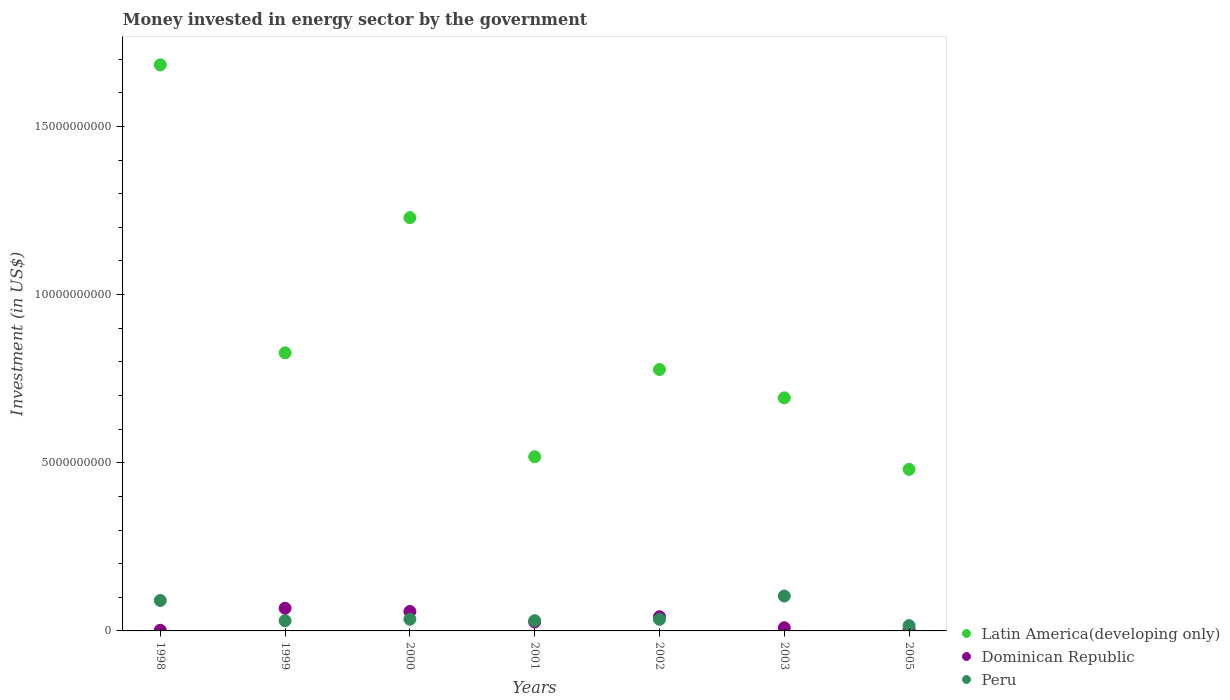What is the money spent in energy sector in Dominican Republic in 2000?
Ensure brevity in your answer.  5.77e+08. Across all years, what is the maximum money spent in energy sector in Latin America(developing only)?
Offer a very short reply. 1.68e+1. In which year was the money spent in energy sector in Dominican Republic maximum?
Your response must be concise. 1999. In which year was the money spent in energy sector in Latin America(developing only) minimum?
Provide a short and direct response. 2005. What is the total money spent in energy sector in Peru in the graph?
Your response must be concise. 3.40e+09. What is the difference between the money spent in energy sector in Peru in 2001 and that in 2005?
Offer a terse response. 1.46e+08. What is the difference between the money spent in energy sector in Latin America(developing only) in 2002 and the money spent in energy sector in Peru in 2001?
Give a very brief answer. 7.47e+09. What is the average money spent in energy sector in Peru per year?
Provide a succinct answer. 4.86e+08. In the year 2000, what is the difference between the money spent in energy sector in Latin America(developing only) and money spent in energy sector in Peru?
Offer a very short reply. 1.19e+1. What is the ratio of the money spent in energy sector in Latin America(developing only) in 2000 to that in 2005?
Offer a very short reply. 2.56. Is the difference between the money spent in energy sector in Latin America(developing only) in 2001 and 2005 greater than the difference between the money spent in energy sector in Peru in 2001 and 2005?
Provide a succinct answer. Yes. What is the difference between the highest and the second highest money spent in energy sector in Dominican Republic?
Your answer should be very brief. 9.67e+07. What is the difference between the highest and the lowest money spent in energy sector in Peru?
Provide a short and direct response. 8.78e+08. Is the sum of the money spent in energy sector in Peru in 2001 and 2003 greater than the maximum money spent in energy sector in Latin America(developing only) across all years?
Make the answer very short. No. What is the difference between two consecutive major ticks on the Y-axis?
Offer a terse response. 5.00e+09. Are the values on the major ticks of Y-axis written in scientific E-notation?
Your answer should be very brief. No. Does the graph contain any zero values?
Offer a terse response. No. Does the graph contain grids?
Make the answer very short. No. How are the legend labels stacked?
Offer a terse response. Vertical. What is the title of the graph?
Your answer should be compact. Money invested in energy sector by the government. Does "Portugal" appear as one of the legend labels in the graph?
Your answer should be very brief. No. What is the label or title of the Y-axis?
Offer a terse response. Investment (in US$). What is the Investment (in US$) in Latin America(developing only) in 1998?
Give a very brief answer. 1.68e+1. What is the Investment (in US$) in Dominican Republic in 1998?
Provide a short and direct response. 2.00e+07. What is the Investment (in US$) in Peru in 1998?
Keep it short and to the point. 9.05e+08. What is the Investment (in US$) in Latin America(developing only) in 1999?
Provide a short and direct response. 8.27e+09. What is the Investment (in US$) in Dominican Republic in 1999?
Make the answer very short. 6.74e+08. What is the Investment (in US$) of Peru in 1999?
Your answer should be compact. 3.04e+08. What is the Investment (in US$) of Latin America(developing only) in 2000?
Your answer should be compact. 1.23e+1. What is the Investment (in US$) of Dominican Republic in 2000?
Offer a very short reply. 5.77e+08. What is the Investment (in US$) of Peru in 2000?
Offer a terse response. 3.48e+08. What is the Investment (in US$) of Latin America(developing only) in 2001?
Offer a terse response. 5.18e+09. What is the Investment (in US$) of Dominican Republic in 2001?
Ensure brevity in your answer.  2.65e+08. What is the Investment (in US$) of Peru in 2001?
Offer a very short reply. 3.04e+08. What is the Investment (in US$) of Latin America(developing only) in 2002?
Make the answer very short. 7.77e+09. What is the Investment (in US$) in Dominican Republic in 2002?
Keep it short and to the point. 4.22e+08. What is the Investment (in US$) in Peru in 2002?
Give a very brief answer. 3.45e+08. What is the Investment (in US$) of Latin America(developing only) in 2003?
Offer a very short reply. 6.93e+09. What is the Investment (in US$) in Dominican Republic in 2003?
Make the answer very short. 9.50e+07. What is the Investment (in US$) in Peru in 2003?
Offer a terse response. 1.04e+09. What is the Investment (in US$) in Latin America(developing only) in 2005?
Provide a short and direct response. 4.80e+09. What is the Investment (in US$) of Dominican Republic in 2005?
Offer a terse response. 4.25e+07. What is the Investment (in US$) of Peru in 2005?
Provide a succinct answer. 1.59e+08. Across all years, what is the maximum Investment (in US$) in Latin America(developing only)?
Your answer should be very brief. 1.68e+1. Across all years, what is the maximum Investment (in US$) in Dominican Republic?
Your answer should be compact. 6.74e+08. Across all years, what is the maximum Investment (in US$) in Peru?
Offer a terse response. 1.04e+09. Across all years, what is the minimum Investment (in US$) of Latin America(developing only)?
Your answer should be compact. 4.80e+09. Across all years, what is the minimum Investment (in US$) of Peru?
Your response must be concise. 1.59e+08. What is the total Investment (in US$) of Latin America(developing only) in the graph?
Your answer should be compact. 6.21e+1. What is the total Investment (in US$) of Dominican Republic in the graph?
Make the answer very short. 2.10e+09. What is the total Investment (in US$) of Peru in the graph?
Keep it short and to the point. 3.40e+09. What is the difference between the Investment (in US$) in Latin America(developing only) in 1998 and that in 1999?
Provide a succinct answer. 8.56e+09. What is the difference between the Investment (in US$) in Dominican Republic in 1998 and that in 1999?
Your answer should be compact. -6.54e+08. What is the difference between the Investment (in US$) in Peru in 1998 and that in 1999?
Your response must be concise. 6.01e+08. What is the difference between the Investment (in US$) in Latin America(developing only) in 1998 and that in 2000?
Provide a short and direct response. 4.54e+09. What is the difference between the Investment (in US$) of Dominican Republic in 1998 and that in 2000?
Keep it short and to the point. -5.57e+08. What is the difference between the Investment (in US$) of Peru in 1998 and that in 2000?
Offer a very short reply. 5.57e+08. What is the difference between the Investment (in US$) of Latin America(developing only) in 1998 and that in 2001?
Make the answer very short. 1.17e+1. What is the difference between the Investment (in US$) of Dominican Republic in 1998 and that in 2001?
Provide a succinct answer. -2.45e+08. What is the difference between the Investment (in US$) of Peru in 1998 and that in 2001?
Your answer should be very brief. 6.01e+08. What is the difference between the Investment (in US$) of Latin America(developing only) in 1998 and that in 2002?
Offer a terse response. 9.06e+09. What is the difference between the Investment (in US$) of Dominican Republic in 1998 and that in 2002?
Ensure brevity in your answer.  -4.02e+08. What is the difference between the Investment (in US$) of Peru in 1998 and that in 2002?
Provide a succinct answer. 5.60e+08. What is the difference between the Investment (in US$) in Latin America(developing only) in 1998 and that in 2003?
Offer a very short reply. 9.90e+09. What is the difference between the Investment (in US$) of Dominican Republic in 1998 and that in 2003?
Your answer should be compact. -7.50e+07. What is the difference between the Investment (in US$) of Peru in 1998 and that in 2003?
Offer a very short reply. -1.32e+08. What is the difference between the Investment (in US$) of Latin America(developing only) in 1998 and that in 2005?
Provide a short and direct response. 1.20e+1. What is the difference between the Investment (in US$) in Dominican Republic in 1998 and that in 2005?
Offer a very short reply. -2.25e+07. What is the difference between the Investment (in US$) in Peru in 1998 and that in 2005?
Provide a short and direct response. 7.46e+08. What is the difference between the Investment (in US$) of Latin America(developing only) in 1999 and that in 2000?
Your response must be concise. -4.02e+09. What is the difference between the Investment (in US$) of Dominican Republic in 1999 and that in 2000?
Give a very brief answer. 9.67e+07. What is the difference between the Investment (in US$) of Peru in 1999 and that in 2000?
Your answer should be compact. -4.37e+07. What is the difference between the Investment (in US$) of Latin America(developing only) in 1999 and that in 2001?
Give a very brief answer. 3.09e+09. What is the difference between the Investment (in US$) in Dominican Republic in 1999 and that in 2001?
Provide a succinct answer. 4.09e+08. What is the difference between the Investment (in US$) of Latin America(developing only) in 1999 and that in 2002?
Your answer should be very brief. 4.96e+08. What is the difference between the Investment (in US$) in Dominican Republic in 1999 and that in 2002?
Offer a very short reply. 2.52e+08. What is the difference between the Investment (in US$) in Peru in 1999 and that in 2002?
Provide a succinct answer. -4.09e+07. What is the difference between the Investment (in US$) in Latin America(developing only) in 1999 and that in 2003?
Your response must be concise. 1.34e+09. What is the difference between the Investment (in US$) in Dominican Republic in 1999 and that in 2003?
Offer a very short reply. 5.79e+08. What is the difference between the Investment (in US$) of Peru in 1999 and that in 2003?
Offer a very short reply. -7.33e+08. What is the difference between the Investment (in US$) of Latin America(developing only) in 1999 and that in 2005?
Make the answer very short. 3.46e+09. What is the difference between the Investment (in US$) of Dominican Republic in 1999 and that in 2005?
Ensure brevity in your answer.  6.32e+08. What is the difference between the Investment (in US$) in Peru in 1999 and that in 2005?
Provide a short and direct response. 1.46e+08. What is the difference between the Investment (in US$) of Latin America(developing only) in 2000 and that in 2001?
Your answer should be very brief. 7.11e+09. What is the difference between the Investment (in US$) in Dominican Republic in 2000 and that in 2001?
Your response must be concise. 3.12e+08. What is the difference between the Investment (in US$) of Peru in 2000 and that in 2001?
Offer a terse response. 4.38e+07. What is the difference between the Investment (in US$) in Latin America(developing only) in 2000 and that in 2002?
Ensure brevity in your answer.  4.52e+09. What is the difference between the Investment (in US$) of Dominican Republic in 2000 and that in 2002?
Provide a short and direct response. 1.56e+08. What is the difference between the Investment (in US$) of Peru in 2000 and that in 2002?
Provide a succinct answer. 2.80e+06. What is the difference between the Investment (in US$) of Latin America(developing only) in 2000 and that in 2003?
Your answer should be very brief. 5.36e+09. What is the difference between the Investment (in US$) of Dominican Republic in 2000 and that in 2003?
Provide a succinct answer. 4.82e+08. What is the difference between the Investment (in US$) of Peru in 2000 and that in 2003?
Your answer should be very brief. -6.89e+08. What is the difference between the Investment (in US$) of Latin America(developing only) in 2000 and that in 2005?
Offer a very short reply. 7.48e+09. What is the difference between the Investment (in US$) of Dominican Republic in 2000 and that in 2005?
Ensure brevity in your answer.  5.35e+08. What is the difference between the Investment (in US$) of Peru in 2000 and that in 2005?
Your response must be concise. 1.90e+08. What is the difference between the Investment (in US$) in Latin America(developing only) in 2001 and that in 2002?
Provide a succinct answer. -2.59e+09. What is the difference between the Investment (in US$) in Dominican Republic in 2001 and that in 2002?
Give a very brief answer. -1.57e+08. What is the difference between the Investment (in US$) in Peru in 2001 and that in 2002?
Your response must be concise. -4.10e+07. What is the difference between the Investment (in US$) of Latin America(developing only) in 2001 and that in 2003?
Give a very brief answer. -1.75e+09. What is the difference between the Investment (in US$) of Dominican Republic in 2001 and that in 2003?
Provide a succinct answer. 1.70e+08. What is the difference between the Investment (in US$) of Peru in 2001 and that in 2003?
Provide a short and direct response. -7.33e+08. What is the difference between the Investment (in US$) in Latin America(developing only) in 2001 and that in 2005?
Ensure brevity in your answer.  3.74e+08. What is the difference between the Investment (in US$) in Dominican Republic in 2001 and that in 2005?
Provide a short and direct response. 2.22e+08. What is the difference between the Investment (in US$) of Peru in 2001 and that in 2005?
Offer a very short reply. 1.46e+08. What is the difference between the Investment (in US$) of Latin America(developing only) in 2002 and that in 2003?
Offer a very short reply. 8.42e+08. What is the difference between the Investment (in US$) of Dominican Republic in 2002 and that in 2003?
Give a very brief answer. 3.27e+08. What is the difference between the Investment (in US$) of Peru in 2002 and that in 2003?
Keep it short and to the point. -6.92e+08. What is the difference between the Investment (in US$) of Latin America(developing only) in 2002 and that in 2005?
Offer a terse response. 2.97e+09. What is the difference between the Investment (in US$) of Dominican Republic in 2002 and that in 2005?
Your answer should be compact. 3.79e+08. What is the difference between the Investment (in US$) of Peru in 2002 and that in 2005?
Provide a succinct answer. 1.87e+08. What is the difference between the Investment (in US$) of Latin America(developing only) in 2003 and that in 2005?
Your response must be concise. 2.13e+09. What is the difference between the Investment (in US$) of Dominican Republic in 2003 and that in 2005?
Make the answer very short. 5.25e+07. What is the difference between the Investment (in US$) in Peru in 2003 and that in 2005?
Keep it short and to the point. 8.78e+08. What is the difference between the Investment (in US$) of Latin America(developing only) in 1998 and the Investment (in US$) of Dominican Republic in 1999?
Offer a terse response. 1.62e+1. What is the difference between the Investment (in US$) of Latin America(developing only) in 1998 and the Investment (in US$) of Peru in 1999?
Keep it short and to the point. 1.65e+1. What is the difference between the Investment (in US$) in Dominican Republic in 1998 and the Investment (in US$) in Peru in 1999?
Give a very brief answer. -2.84e+08. What is the difference between the Investment (in US$) in Latin America(developing only) in 1998 and the Investment (in US$) in Dominican Republic in 2000?
Offer a very short reply. 1.63e+1. What is the difference between the Investment (in US$) in Latin America(developing only) in 1998 and the Investment (in US$) in Peru in 2000?
Keep it short and to the point. 1.65e+1. What is the difference between the Investment (in US$) in Dominican Republic in 1998 and the Investment (in US$) in Peru in 2000?
Your response must be concise. -3.28e+08. What is the difference between the Investment (in US$) of Latin America(developing only) in 1998 and the Investment (in US$) of Dominican Republic in 2001?
Your answer should be very brief. 1.66e+1. What is the difference between the Investment (in US$) in Latin America(developing only) in 1998 and the Investment (in US$) in Peru in 2001?
Ensure brevity in your answer.  1.65e+1. What is the difference between the Investment (in US$) of Dominican Republic in 1998 and the Investment (in US$) of Peru in 2001?
Provide a succinct answer. -2.84e+08. What is the difference between the Investment (in US$) in Latin America(developing only) in 1998 and the Investment (in US$) in Dominican Republic in 2002?
Provide a succinct answer. 1.64e+1. What is the difference between the Investment (in US$) in Latin America(developing only) in 1998 and the Investment (in US$) in Peru in 2002?
Offer a terse response. 1.65e+1. What is the difference between the Investment (in US$) in Dominican Republic in 1998 and the Investment (in US$) in Peru in 2002?
Provide a succinct answer. -3.25e+08. What is the difference between the Investment (in US$) in Latin America(developing only) in 1998 and the Investment (in US$) in Dominican Republic in 2003?
Keep it short and to the point. 1.67e+1. What is the difference between the Investment (in US$) of Latin America(developing only) in 1998 and the Investment (in US$) of Peru in 2003?
Give a very brief answer. 1.58e+1. What is the difference between the Investment (in US$) of Dominican Republic in 1998 and the Investment (in US$) of Peru in 2003?
Give a very brief answer. -1.02e+09. What is the difference between the Investment (in US$) in Latin America(developing only) in 1998 and the Investment (in US$) in Dominican Republic in 2005?
Your response must be concise. 1.68e+1. What is the difference between the Investment (in US$) in Latin America(developing only) in 1998 and the Investment (in US$) in Peru in 2005?
Your answer should be very brief. 1.67e+1. What is the difference between the Investment (in US$) in Dominican Republic in 1998 and the Investment (in US$) in Peru in 2005?
Your answer should be compact. -1.39e+08. What is the difference between the Investment (in US$) of Latin America(developing only) in 1999 and the Investment (in US$) of Dominican Republic in 2000?
Your answer should be very brief. 7.69e+09. What is the difference between the Investment (in US$) in Latin America(developing only) in 1999 and the Investment (in US$) in Peru in 2000?
Keep it short and to the point. 7.92e+09. What is the difference between the Investment (in US$) in Dominican Republic in 1999 and the Investment (in US$) in Peru in 2000?
Offer a very short reply. 3.26e+08. What is the difference between the Investment (in US$) of Latin America(developing only) in 1999 and the Investment (in US$) of Dominican Republic in 2001?
Offer a terse response. 8.00e+09. What is the difference between the Investment (in US$) of Latin America(developing only) in 1999 and the Investment (in US$) of Peru in 2001?
Your response must be concise. 7.96e+09. What is the difference between the Investment (in US$) in Dominican Republic in 1999 and the Investment (in US$) in Peru in 2001?
Ensure brevity in your answer.  3.70e+08. What is the difference between the Investment (in US$) of Latin America(developing only) in 1999 and the Investment (in US$) of Dominican Republic in 2002?
Your answer should be very brief. 7.85e+09. What is the difference between the Investment (in US$) of Latin America(developing only) in 1999 and the Investment (in US$) of Peru in 2002?
Make the answer very short. 7.92e+09. What is the difference between the Investment (in US$) in Dominican Republic in 1999 and the Investment (in US$) in Peru in 2002?
Your response must be concise. 3.29e+08. What is the difference between the Investment (in US$) in Latin America(developing only) in 1999 and the Investment (in US$) in Dominican Republic in 2003?
Keep it short and to the point. 8.17e+09. What is the difference between the Investment (in US$) of Latin America(developing only) in 1999 and the Investment (in US$) of Peru in 2003?
Ensure brevity in your answer.  7.23e+09. What is the difference between the Investment (in US$) in Dominican Republic in 1999 and the Investment (in US$) in Peru in 2003?
Make the answer very short. -3.63e+08. What is the difference between the Investment (in US$) of Latin America(developing only) in 1999 and the Investment (in US$) of Dominican Republic in 2005?
Your answer should be compact. 8.23e+09. What is the difference between the Investment (in US$) of Latin America(developing only) in 1999 and the Investment (in US$) of Peru in 2005?
Provide a short and direct response. 8.11e+09. What is the difference between the Investment (in US$) of Dominican Republic in 1999 and the Investment (in US$) of Peru in 2005?
Keep it short and to the point. 5.15e+08. What is the difference between the Investment (in US$) in Latin America(developing only) in 2000 and the Investment (in US$) in Dominican Republic in 2001?
Ensure brevity in your answer.  1.20e+1. What is the difference between the Investment (in US$) of Latin America(developing only) in 2000 and the Investment (in US$) of Peru in 2001?
Provide a succinct answer. 1.20e+1. What is the difference between the Investment (in US$) of Dominican Republic in 2000 and the Investment (in US$) of Peru in 2001?
Your answer should be very brief. 2.73e+08. What is the difference between the Investment (in US$) of Latin America(developing only) in 2000 and the Investment (in US$) of Dominican Republic in 2002?
Your response must be concise. 1.19e+1. What is the difference between the Investment (in US$) of Latin America(developing only) in 2000 and the Investment (in US$) of Peru in 2002?
Provide a short and direct response. 1.19e+1. What is the difference between the Investment (in US$) in Dominican Republic in 2000 and the Investment (in US$) in Peru in 2002?
Give a very brief answer. 2.32e+08. What is the difference between the Investment (in US$) of Latin America(developing only) in 2000 and the Investment (in US$) of Dominican Republic in 2003?
Offer a terse response. 1.22e+1. What is the difference between the Investment (in US$) in Latin America(developing only) in 2000 and the Investment (in US$) in Peru in 2003?
Provide a short and direct response. 1.13e+1. What is the difference between the Investment (in US$) of Dominican Republic in 2000 and the Investment (in US$) of Peru in 2003?
Your answer should be very brief. -4.60e+08. What is the difference between the Investment (in US$) in Latin America(developing only) in 2000 and the Investment (in US$) in Dominican Republic in 2005?
Offer a very short reply. 1.22e+1. What is the difference between the Investment (in US$) of Latin America(developing only) in 2000 and the Investment (in US$) of Peru in 2005?
Provide a short and direct response. 1.21e+1. What is the difference between the Investment (in US$) of Dominican Republic in 2000 and the Investment (in US$) of Peru in 2005?
Your answer should be compact. 4.19e+08. What is the difference between the Investment (in US$) in Latin America(developing only) in 2001 and the Investment (in US$) in Dominican Republic in 2002?
Keep it short and to the point. 4.76e+09. What is the difference between the Investment (in US$) in Latin America(developing only) in 2001 and the Investment (in US$) in Peru in 2002?
Make the answer very short. 4.83e+09. What is the difference between the Investment (in US$) in Dominican Republic in 2001 and the Investment (in US$) in Peru in 2002?
Offer a very short reply. -8.03e+07. What is the difference between the Investment (in US$) of Latin America(developing only) in 2001 and the Investment (in US$) of Dominican Republic in 2003?
Provide a short and direct response. 5.08e+09. What is the difference between the Investment (in US$) of Latin America(developing only) in 2001 and the Investment (in US$) of Peru in 2003?
Your answer should be compact. 4.14e+09. What is the difference between the Investment (in US$) of Dominican Republic in 2001 and the Investment (in US$) of Peru in 2003?
Keep it short and to the point. -7.72e+08. What is the difference between the Investment (in US$) of Latin America(developing only) in 2001 and the Investment (in US$) of Dominican Republic in 2005?
Ensure brevity in your answer.  5.14e+09. What is the difference between the Investment (in US$) in Latin America(developing only) in 2001 and the Investment (in US$) in Peru in 2005?
Your response must be concise. 5.02e+09. What is the difference between the Investment (in US$) in Dominican Republic in 2001 and the Investment (in US$) in Peru in 2005?
Provide a short and direct response. 1.06e+08. What is the difference between the Investment (in US$) of Latin America(developing only) in 2002 and the Investment (in US$) of Dominican Republic in 2003?
Your response must be concise. 7.68e+09. What is the difference between the Investment (in US$) in Latin America(developing only) in 2002 and the Investment (in US$) in Peru in 2003?
Offer a terse response. 6.74e+09. What is the difference between the Investment (in US$) in Dominican Republic in 2002 and the Investment (in US$) in Peru in 2003?
Ensure brevity in your answer.  -6.15e+08. What is the difference between the Investment (in US$) in Latin America(developing only) in 2002 and the Investment (in US$) in Dominican Republic in 2005?
Provide a short and direct response. 7.73e+09. What is the difference between the Investment (in US$) of Latin America(developing only) in 2002 and the Investment (in US$) of Peru in 2005?
Your answer should be compact. 7.61e+09. What is the difference between the Investment (in US$) in Dominican Republic in 2002 and the Investment (in US$) in Peru in 2005?
Provide a succinct answer. 2.63e+08. What is the difference between the Investment (in US$) of Latin America(developing only) in 2003 and the Investment (in US$) of Dominican Republic in 2005?
Keep it short and to the point. 6.89e+09. What is the difference between the Investment (in US$) in Latin America(developing only) in 2003 and the Investment (in US$) in Peru in 2005?
Provide a succinct answer. 6.77e+09. What is the difference between the Investment (in US$) of Dominican Republic in 2003 and the Investment (in US$) of Peru in 2005?
Your response must be concise. -6.36e+07. What is the average Investment (in US$) of Latin America(developing only) per year?
Give a very brief answer. 8.87e+09. What is the average Investment (in US$) of Dominican Republic per year?
Provide a succinct answer. 2.99e+08. What is the average Investment (in US$) in Peru per year?
Keep it short and to the point. 4.86e+08. In the year 1998, what is the difference between the Investment (in US$) of Latin America(developing only) and Investment (in US$) of Dominican Republic?
Ensure brevity in your answer.  1.68e+1. In the year 1998, what is the difference between the Investment (in US$) of Latin America(developing only) and Investment (in US$) of Peru?
Your response must be concise. 1.59e+1. In the year 1998, what is the difference between the Investment (in US$) of Dominican Republic and Investment (in US$) of Peru?
Offer a very short reply. -8.85e+08. In the year 1999, what is the difference between the Investment (in US$) of Latin America(developing only) and Investment (in US$) of Dominican Republic?
Your answer should be very brief. 7.59e+09. In the year 1999, what is the difference between the Investment (in US$) in Latin America(developing only) and Investment (in US$) in Peru?
Provide a succinct answer. 7.96e+09. In the year 1999, what is the difference between the Investment (in US$) in Dominican Republic and Investment (in US$) in Peru?
Your answer should be compact. 3.70e+08. In the year 2000, what is the difference between the Investment (in US$) in Latin America(developing only) and Investment (in US$) in Dominican Republic?
Provide a short and direct response. 1.17e+1. In the year 2000, what is the difference between the Investment (in US$) of Latin America(developing only) and Investment (in US$) of Peru?
Provide a succinct answer. 1.19e+1. In the year 2000, what is the difference between the Investment (in US$) of Dominican Republic and Investment (in US$) of Peru?
Keep it short and to the point. 2.29e+08. In the year 2001, what is the difference between the Investment (in US$) of Latin America(developing only) and Investment (in US$) of Dominican Republic?
Offer a very short reply. 4.91e+09. In the year 2001, what is the difference between the Investment (in US$) of Latin America(developing only) and Investment (in US$) of Peru?
Your answer should be compact. 4.87e+09. In the year 2001, what is the difference between the Investment (in US$) of Dominican Republic and Investment (in US$) of Peru?
Provide a short and direct response. -3.93e+07. In the year 2002, what is the difference between the Investment (in US$) in Latin America(developing only) and Investment (in US$) in Dominican Republic?
Offer a very short reply. 7.35e+09. In the year 2002, what is the difference between the Investment (in US$) of Latin America(developing only) and Investment (in US$) of Peru?
Your response must be concise. 7.43e+09. In the year 2002, what is the difference between the Investment (in US$) in Dominican Republic and Investment (in US$) in Peru?
Provide a succinct answer. 7.65e+07. In the year 2003, what is the difference between the Investment (in US$) of Latin America(developing only) and Investment (in US$) of Dominican Republic?
Your answer should be very brief. 6.83e+09. In the year 2003, what is the difference between the Investment (in US$) in Latin America(developing only) and Investment (in US$) in Peru?
Offer a terse response. 5.89e+09. In the year 2003, what is the difference between the Investment (in US$) of Dominican Republic and Investment (in US$) of Peru?
Keep it short and to the point. -9.42e+08. In the year 2005, what is the difference between the Investment (in US$) in Latin America(developing only) and Investment (in US$) in Dominican Republic?
Make the answer very short. 4.76e+09. In the year 2005, what is the difference between the Investment (in US$) in Latin America(developing only) and Investment (in US$) in Peru?
Offer a terse response. 4.65e+09. In the year 2005, what is the difference between the Investment (in US$) in Dominican Republic and Investment (in US$) in Peru?
Keep it short and to the point. -1.16e+08. What is the ratio of the Investment (in US$) in Latin America(developing only) in 1998 to that in 1999?
Ensure brevity in your answer.  2.04. What is the ratio of the Investment (in US$) of Dominican Republic in 1998 to that in 1999?
Your answer should be compact. 0.03. What is the ratio of the Investment (in US$) of Peru in 1998 to that in 1999?
Offer a terse response. 2.97. What is the ratio of the Investment (in US$) of Latin America(developing only) in 1998 to that in 2000?
Ensure brevity in your answer.  1.37. What is the ratio of the Investment (in US$) of Dominican Republic in 1998 to that in 2000?
Give a very brief answer. 0.03. What is the ratio of the Investment (in US$) of Peru in 1998 to that in 2000?
Make the answer very short. 2.6. What is the ratio of the Investment (in US$) of Latin America(developing only) in 1998 to that in 2001?
Offer a very short reply. 3.25. What is the ratio of the Investment (in US$) of Dominican Republic in 1998 to that in 2001?
Provide a succinct answer. 0.08. What is the ratio of the Investment (in US$) in Peru in 1998 to that in 2001?
Make the answer very short. 2.97. What is the ratio of the Investment (in US$) in Latin America(developing only) in 1998 to that in 2002?
Give a very brief answer. 2.17. What is the ratio of the Investment (in US$) in Dominican Republic in 1998 to that in 2002?
Ensure brevity in your answer.  0.05. What is the ratio of the Investment (in US$) of Peru in 1998 to that in 2002?
Keep it short and to the point. 2.62. What is the ratio of the Investment (in US$) in Latin America(developing only) in 1998 to that in 2003?
Keep it short and to the point. 2.43. What is the ratio of the Investment (in US$) of Dominican Republic in 1998 to that in 2003?
Offer a very short reply. 0.21. What is the ratio of the Investment (in US$) of Peru in 1998 to that in 2003?
Ensure brevity in your answer.  0.87. What is the ratio of the Investment (in US$) of Latin America(developing only) in 1998 to that in 2005?
Make the answer very short. 3.5. What is the ratio of the Investment (in US$) of Dominican Republic in 1998 to that in 2005?
Ensure brevity in your answer.  0.47. What is the ratio of the Investment (in US$) of Peru in 1998 to that in 2005?
Your answer should be very brief. 5.71. What is the ratio of the Investment (in US$) of Latin America(developing only) in 1999 to that in 2000?
Your answer should be compact. 0.67. What is the ratio of the Investment (in US$) of Dominican Republic in 1999 to that in 2000?
Your response must be concise. 1.17. What is the ratio of the Investment (in US$) of Peru in 1999 to that in 2000?
Make the answer very short. 0.87. What is the ratio of the Investment (in US$) of Latin America(developing only) in 1999 to that in 2001?
Your answer should be compact. 1.6. What is the ratio of the Investment (in US$) of Dominican Republic in 1999 to that in 2001?
Provide a succinct answer. 2.54. What is the ratio of the Investment (in US$) in Peru in 1999 to that in 2001?
Your response must be concise. 1. What is the ratio of the Investment (in US$) in Latin America(developing only) in 1999 to that in 2002?
Your answer should be compact. 1.06. What is the ratio of the Investment (in US$) in Dominican Republic in 1999 to that in 2002?
Offer a very short reply. 1.6. What is the ratio of the Investment (in US$) of Peru in 1999 to that in 2002?
Provide a succinct answer. 0.88. What is the ratio of the Investment (in US$) of Latin America(developing only) in 1999 to that in 2003?
Your answer should be very brief. 1.19. What is the ratio of the Investment (in US$) of Dominican Republic in 1999 to that in 2003?
Give a very brief answer. 7.09. What is the ratio of the Investment (in US$) in Peru in 1999 to that in 2003?
Your answer should be very brief. 0.29. What is the ratio of the Investment (in US$) of Latin America(developing only) in 1999 to that in 2005?
Keep it short and to the point. 1.72. What is the ratio of the Investment (in US$) in Dominican Republic in 1999 to that in 2005?
Provide a succinct answer. 15.86. What is the ratio of the Investment (in US$) of Peru in 1999 to that in 2005?
Give a very brief answer. 1.92. What is the ratio of the Investment (in US$) of Latin America(developing only) in 2000 to that in 2001?
Keep it short and to the point. 2.37. What is the ratio of the Investment (in US$) in Dominican Republic in 2000 to that in 2001?
Your answer should be very brief. 2.18. What is the ratio of the Investment (in US$) of Peru in 2000 to that in 2001?
Your answer should be compact. 1.14. What is the ratio of the Investment (in US$) in Latin America(developing only) in 2000 to that in 2002?
Keep it short and to the point. 1.58. What is the ratio of the Investment (in US$) in Dominican Republic in 2000 to that in 2002?
Offer a terse response. 1.37. What is the ratio of the Investment (in US$) in Latin America(developing only) in 2000 to that in 2003?
Provide a short and direct response. 1.77. What is the ratio of the Investment (in US$) in Dominican Republic in 2000 to that in 2003?
Offer a very short reply. 6.08. What is the ratio of the Investment (in US$) of Peru in 2000 to that in 2003?
Offer a very short reply. 0.34. What is the ratio of the Investment (in US$) of Latin America(developing only) in 2000 to that in 2005?
Keep it short and to the point. 2.56. What is the ratio of the Investment (in US$) of Dominican Republic in 2000 to that in 2005?
Provide a short and direct response. 13.58. What is the ratio of the Investment (in US$) in Peru in 2000 to that in 2005?
Provide a short and direct response. 2.19. What is the ratio of the Investment (in US$) in Latin America(developing only) in 2001 to that in 2002?
Ensure brevity in your answer.  0.67. What is the ratio of the Investment (in US$) of Dominican Republic in 2001 to that in 2002?
Keep it short and to the point. 0.63. What is the ratio of the Investment (in US$) in Peru in 2001 to that in 2002?
Provide a short and direct response. 0.88. What is the ratio of the Investment (in US$) of Latin America(developing only) in 2001 to that in 2003?
Your answer should be compact. 0.75. What is the ratio of the Investment (in US$) in Dominican Republic in 2001 to that in 2003?
Provide a short and direct response. 2.79. What is the ratio of the Investment (in US$) of Peru in 2001 to that in 2003?
Keep it short and to the point. 0.29. What is the ratio of the Investment (in US$) of Latin America(developing only) in 2001 to that in 2005?
Your answer should be compact. 1.08. What is the ratio of the Investment (in US$) in Dominican Republic in 2001 to that in 2005?
Your response must be concise. 6.24. What is the ratio of the Investment (in US$) of Peru in 2001 to that in 2005?
Provide a succinct answer. 1.92. What is the ratio of the Investment (in US$) of Latin America(developing only) in 2002 to that in 2003?
Your answer should be compact. 1.12. What is the ratio of the Investment (in US$) in Dominican Republic in 2002 to that in 2003?
Make the answer very short. 4.44. What is the ratio of the Investment (in US$) in Peru in 2002 to that in 2003?
Ensure brevity in your answer.  0.33. What is the ratio of the Investment (in US$) in Latin America(developing only) in 2002 to that in 2005?
Provide a succinct answer. 1.62. What is the ratio of the Investment (in US$) of Dominican Republic in 2002 to that in 2005?
Offer a very short reply. 9.92. What is the ratio of the Investment (in US$) of Peru in 2002 to that in 2005?
Keep it short and to the point. 2.18. What is the ratio of the Investment (in US$) of Latin America(developing only) in 2003 to that in 2005?
Ensure brevity in your answer.  1.44. What is the ratio of the Investment (in US$) of Dominican Republic in 2003 to that in 2005?
Offer a very short reply. 2.24. What is the ratio of the Investment (in US$) in Peru in 2003 to that in 2005?
Ensure brevity in your answer.  6.54. What is the difference between the highest and the second highest Investment (in US$) in Latin America(developing only)?
Your response must be concise. 4.54e+09. What is the difference between the highest and the second highest Investment (in US$) in Dominican Republic?
Your answer should be compact. 9.67e+07. What is the difference between the highest and the second highest Investment (in US$) of Peru?
Your answer should be compact. 1.32e+08. What is the difference between the highest and the lowest Investment (in US$) in Latin America(developing only)?
Your answer should be compact. 1.20e+1. What is the difference between the highest and the lowest Investment (in US$) of Dominican Republic?
Your response must be concise. 6.54e+08. What is the difference between the highest and the lowest Investment (in US$) in Peru?
Provide a short and direct response. 8.78e+08. 